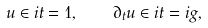<formula> <loc_0><loc_0><loc_500><loc_500>u \in i t = 1 , \quad \partial _ { t } u \in i t = i g ,</formula> 